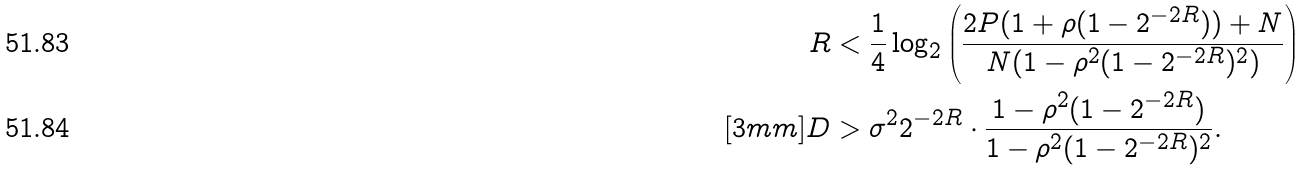<formula> <loc_0><loc_0><loc_500><loc_500>R & < \frac { 1 } { 4 } \log _ { 2 } \left ( \frac { 2 P ( 1 + \rho ( 1 - 2 ^ { - 2 R } ) ) + N } { N ( 1 - \rho ^ { 2 } ( 1 - 2 ^ { - 2 R } ) ^ { 2 } ) } \right ) \\ [ 3 m m ] D & > \sigma ^ { 2 } 2 ^ { - 2 R } \cdot \frac { 1 - \rho ^ { 2 } ( 1 - 2 ^ { - 2 R } ) } { 1 - \rho ^ { 2 } ( 1 - 2 ^ { - 2 R } ) ^ { 2 } } .</formula> 